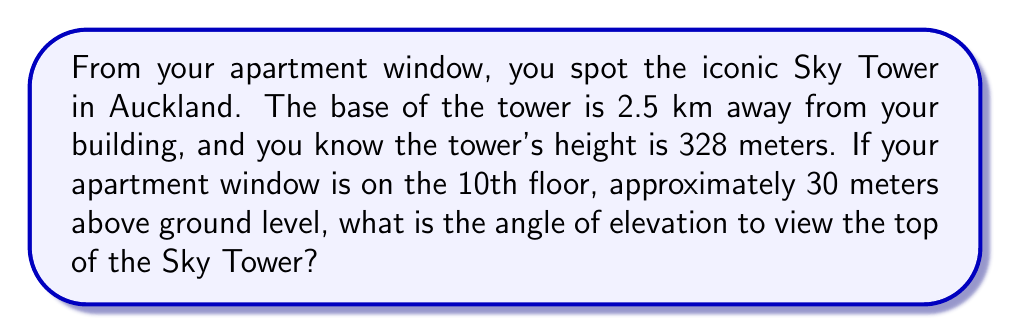Can you solve this math problem? Let's approach this step-by-step:

1) First, we need to find the height difference between your window and the top of the Sky Tower:
   $328 \text{ m} - 30 \text{ m} = 298 \text{ m}$

2) Now we have a right triangle where:
   - The adjacent side is the horizontal distance to the tower: 2500 m
   - The opposite side is the height difference: 298 m
   - We need to find the angle of elevation

3) We can use the tangent function to find this angle:

   $$\tan(\theta) = \frac{\text{opposite}}{\text{adjacent}} = \frac{298}{2500}$$

4) To find the angle, we need to use the inverse tangent (arctan or $\tan^{-1}$):

   $$\theta = \tan^{-1}\left(\frac{298}{2500}\right)$$

5) Using a calculator or computer:

   $$\theta \approx 6.80^\circ$$

[asy]
import geometry;

size(200);
pair A = (0,0), B = (10,0), C = (10,1.19);
draw(A--B--C--A);
label("2500 m", (5,0), S);
label("298 m", (10,0.6), E);
label("$\theta$", (0.3,0.1), NW);
draw(arc(A,0.5,0,6.80), Arrow);
[/asy]
Answer: $6.80^\circ$ 